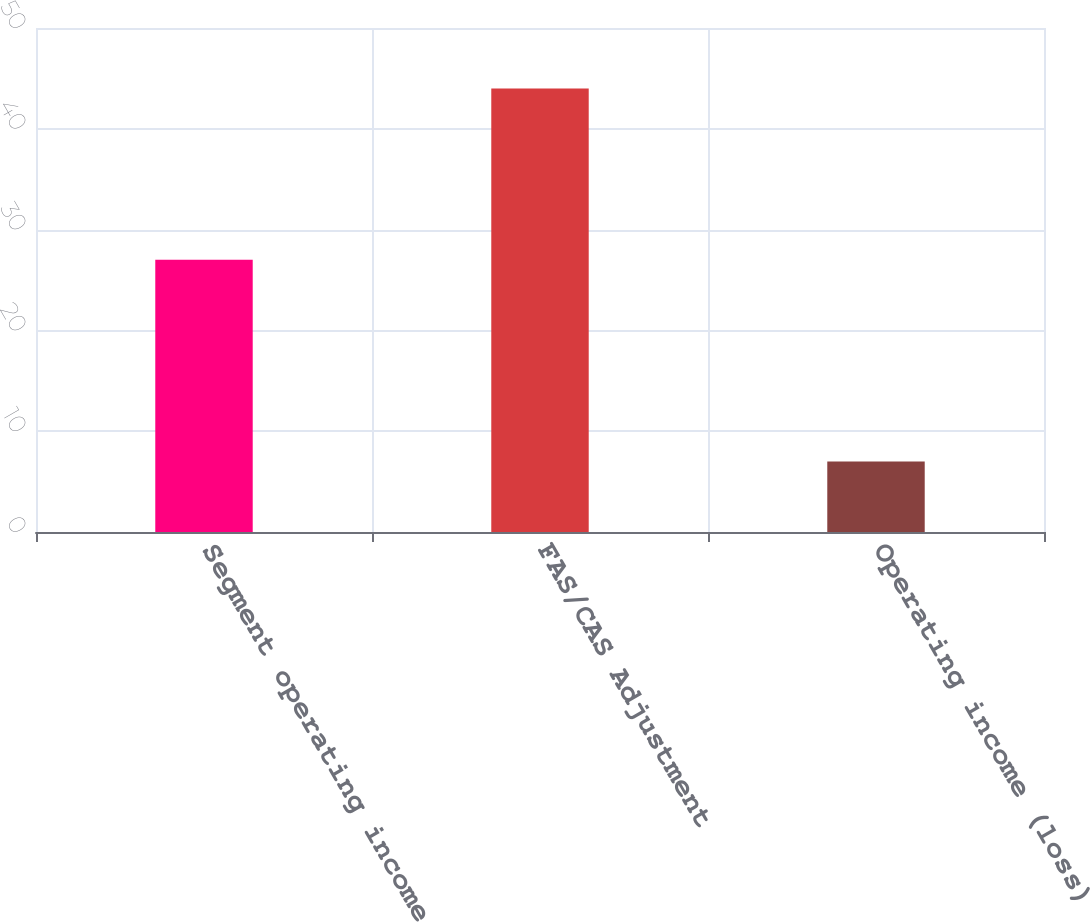Convert chart to OTSL. <chart><loc_0><loc_0><loc_500><loc_500><bar_chart><fcel>Segment operating income<fcel>FAS/CAS Adjustment<fcel>Operating income (loss)<nl><fcel>27<fcel>44<fcel>7<nl></chart> 